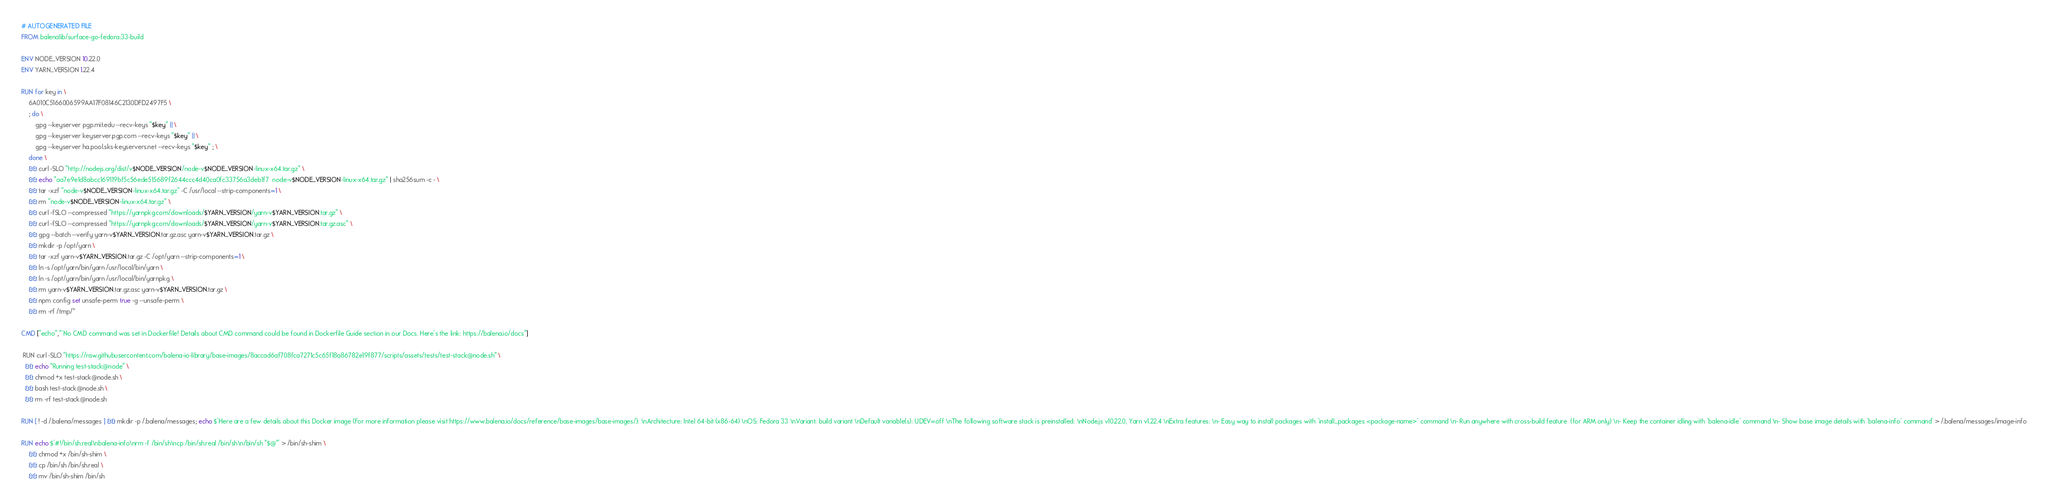<code> <loc_0><loc_0><loc_500><loc_500><_Dockerfile_># AUTOGENERATED FILE
FROM balenalib/surface-go-fedora:33-build

ENV NODE_VERSION 10.22.0
ENV YARN_VERSION 1.22.4

RUN for key in \
	6A010C5166006599AA17F08146C2130DFD2497F5 \
	; do \
		gpg --keyserver pgp.mit.edu --recv-keys "$key" || \
		gpg --keyserver keyserver.pgp.com --recv-keys "$key" || \
		gpg --keyserver ha.pool.sks-keyservers.net --recv-keys "$key" ; \
	done \
	&& curl -SLO "http://nodejs.org/dist/v$NODE_VERSION/node-v$NODE_VERSION-linux-x64.tar.gz" \
	&& echo "aa7e9e1d8abcc169119bf5c56ede515689f2644ccc4d40ca0fc33756a3deb1f7  node-v$NODE_VERSION-linux-x64.tar.gz" | sha256sum -c - \
	&& tar -xzf "node-v$NODE_VERSION-linux-x64.tar.gz" -C /usr/local --strip-components=1 \
	&& rm "node-v$NODE_VERSION-linux-x64.tar.gz" \
	&& curl -fSLO --compressed "https://yarnpkg.com/downloads/$YARN_VERSION/yarn-v$YARN_VERSION.tar.gz" \
	&& curl -fSLO --compressed "https://yarnpkg.com/downloads/$YARN_VERSION/yarn-v$YARN_VERSION.tar.gz.asc" \
	&& gpg --batch --verify yarn-v$YARN_VERSION.tar.gz.asc yarn-v$YARN_VERSION.tar.gz \
	&& mkdir -p /opt/yarn \
	&& tar -xzf yarn-v$YARN_VERSION.tar.gz -C /opt/yarn --strip-components=1 \
	&& ln -s /opt/yarn/bin/yarn /usr/local/bin/yarn \
	&& ln -s /opt/yarn/bin/yarn /usr/local/bin/yarnpkg \
	&& rm yarn-v$YARN_VERSION.tar.gz.asc yarn-v$YARN_VERSION.tar.gz \
	&& npm config set unsafe-perm true -g --unsafe-perm \
	&& rm -rf /tmp/*

CMD ["echo","'No CMD command was set in Dockerfile! Details about CMD command could be found in Dockerfile Guide section in our Docs. Here's the link: https://balena.io/docs"]

 RUN curl -SLO "https://raw.githubusercontent.com/balena-io-library/base-images/8accad6af708fca7271c5c65f18a86782e19f877/scripts/assets/tests/test-stack@node.sh" \
  && echo "Running test-stack@node" \
  && chmod +x test-stack@node.sh \
  && bash test-stack@node.sh \
  && rm -rf test-stack@node.sh 

RUN [ ! -d /.balena/messages ] && mkdir -p /.balena/messages; echo $'Here are a few details about this Docker image (For more information please visit https://www.balena.io/docs/reference/base-images/base-images/): \nArchitecture: Intel 64-bit (x86-64) \nOS: Fedora 33 \nVariant: build variant \nDefault variable(s): UDEV=off \nThe following software stack is preinstalled: \nNode.js v10.22.0, Yarn v1.22.4 \nExtra features: \n- Easy way to install packages with `install_packages <package-name>` command \n- Run anywhere with cross-build feature  (for ARM only) \n- Keep the container idling with `balena-idle` command \n- Show base image details with `balena-info` command' > /.balena/messages/image-info

RUN echo $'#!/bin/sh.real\nbalena-info\nrm -f /bin/sh\ncp /bin/sh.real /bin/sh\n/bin/sh "$@"' > /bin/sh-shim \
	&& chmod +x /bin/sh-shim \
	&& cp /bin/sh /bin/sh.real \
	&& mv /bin/sh-shim /bin/sh</code> 